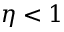Convert formula to latex. <formula><loc_0><loc_0><loc_500><loc_500>\eta < 1</formula> 